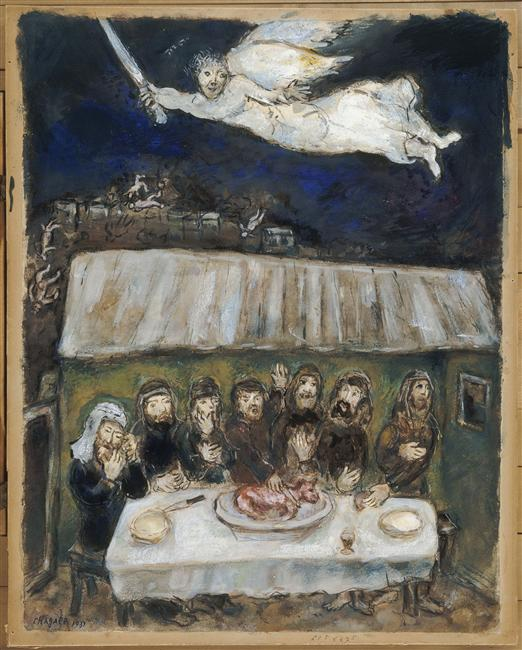What story could tie together the people, the angel, and the piece of meat? In an age-old village under a moonlit night, a community gathers to perform a sacred ritual, summoning protection against the oncoming chaos threatening their peace. As they circle around the table, the centerpiece of their ritual—a piece of sacred meat—receives their collective prayers. Suddenly, an ethereal being, an angel with a sword, appears above, embodying the divine response to their heartfelt pleas. Raising the sword signifies the acceptance of their offering and the promise of safeguarding and guidance in their troubled times, bringing a sense of hope and assurance among the gathered villagers. 